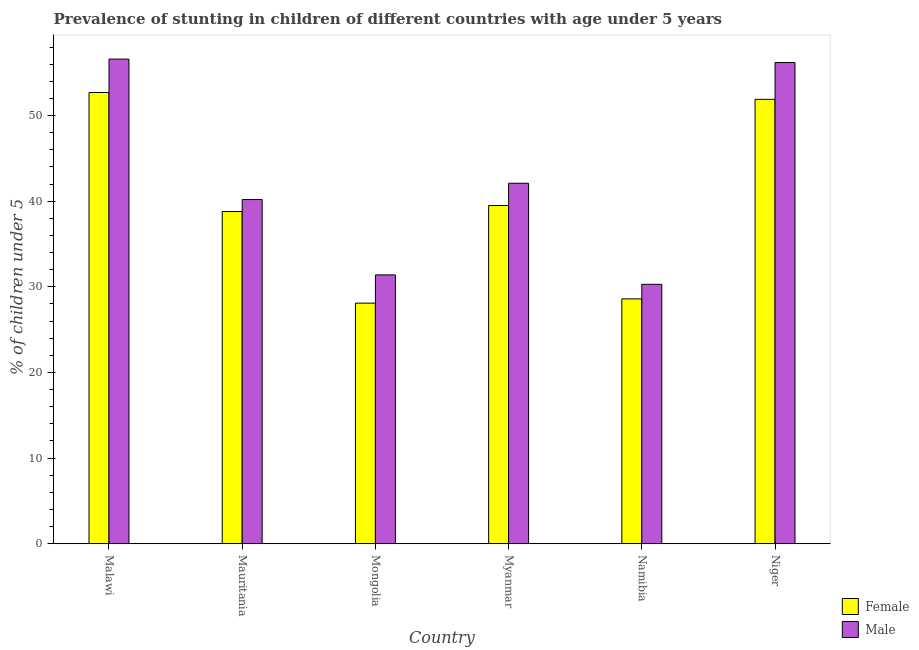How many different coloured bars are there?
Make the answer very short. 2. How many groups of bars are there?
Provide a short and direct response. 6. Are the number of bars per tick equal to the number of legend labels?
Your answer should be very brief. Yes. Are the number of bars on each tick of the X-axis equal?
Ensure brevity in your answer.  Yes. How many bars are there on the 2nd tick from the left?
Keep it short and to the point. 2. How many bars are there on the 5th tick from the right?
Make the answer very short. 2. What is the label of the 3rd group of bars from the left?
Offer a terse response. Mongolia. In how many cases, is the number of bars for a given country not equal to the number of legend labels?
Provide a succinct answer. 0. What is the percentage of stunted male children in Mauritania?
Provide a short and direct response. 40.2. Across all countries, what is the maximum percentage of stunted female children?
Your response must be concise. 52.7. Across all countries, what is the minimum percentage of stunted female children?
Provide a succinct answer. 28.1. In which country was the percentage of stunted male children maximum?
Provide a short and direct response. Malawi. In which country was the percentage of stunted female children minimum?
Your answer should be compact. Mongolia. What is the total percentage of stunted female children in the graph?
Offer a very short reply. 239.6. What is the difference between the percentage of stunted male children in Malawi and that in Namibia?
Make the answer very short. 26.3. What is the difference between the percentage of stunted female children in Niger and the percentage of stunted male children in Malawi?
Give a very brief answer. -4.7. What is the average percentage of stunted female children per country?
Give a very brief answer. 39.93. What is the difference between the percentage of stunted female children and percentage of stunted male children in Malawi?
Keep it short and to the point. -3.9. What is the ratio of the percentage of stunted female children in Mauritania to that in Niger?
Offer a very short reply. 0.75. Is the difference between the percentage of stunted male children in Mauritania and Namibia greater than the difference between the percentage of stunted female children in Mauritania and Namibia?
Your response must be concise. No. What is the difference between the highest and the second highest percentage of stunted male children?
Offer a very short reply. 0.4. What is the difference between the highest and the lowest percentage of stunted male children?
Your answer should be compact. 26.3. What does the 2nd bar from the left in Myanmar represents?
Offer a terse response. Male. What does the 2nd bar from the right in Myanmar represents?
Your answer should be compact. Female. Are all the bars in the graph horizontal?
Offer a very short reply. No. What is the difference between two consecutive major ticks on the Y-axis?
Offer a very short reply. 10. Does the graph contain grids?
Provide a short and direct response. No. Where does the legend appear in the graph?
Ensure brevity in your answer.  Bottom right. What is the title of the graph?
Give a very brief answer. Prevalence of stunting in children of different countries with age under 5 years. Does "Urban" appear as one of the legend labels in the graph?
Keep it short and to the point. No. What is the label or title of the X-axis?
Ensure brevity in your answer.  Country. What is the label or title of the Y-axis?
Provide a short and direct response.  % of children under 5. What is the  % of children under 5 in Female in Malawi?
Give a very brief answer. 52.7. What is the  % of children under 5 in Male in Malawi?
Keep it short and to the point. 56.6. What is the  % of children under 5 of Female in Mauritania?
Your response must be concise. 38.8. What is the  % of children under 5 in Male in Mauritania?
Your answer should be compact. 40.2. What is the  % of children under 5 in Female in Mongolia?
Your answer should be very brief. 28.1. What is the  % of children under 5 in Male in Mongolia?
Your response must be concise. 31.4. What is the  % of children under 5 of Female in Myanmar?
Keep it short and to the point. 39.5. What is the  % of children under 5 in Male in Myanmar?
Make the answer very short. 42.1. What is the  % of children under 5 of Female in Namibia?
Your answer should be compact. 28.6. What is the  % of children under 5 in Male in Namibia?
Ensure brevity in your answer.  30.3. What is the  % of children under 5 of Female in Niger?
Keep it short and to the point. 51.9. What is the  % of children under 5 of Male in Niger?
Your answer should be compact. 56.2. Across all countries, what is the maximum  % of children under 5 of Female?
Your answer should be compact. 52.7. Across all countries, what is the maximum  % of children under 5 of Male?
Provide a short and direct response. 56.6. Across all countries, what is the minimum  % of children under 5 in Female?
Offer a terse response. 28.1. Across all countries, what is the minimum  % of children under 5 in Male?
Your response must be concise. 30.3. What is the total  % of children under 5 in Female in the graph?
Give a very brief answer. 239.6. What is the total  % of children under 5 in Male in the graph?
Your answer should be compact. 256.8. What is the difference between the  % of children under 5 in Female in Malawi and that in Mauritania?
Provide a succinct answer. 13.9. What is the difference between the  % of children under 5 of Male in Malawi and that in Mauritania?
Keep it short and to the point. 16.4. What is the difference between the  % of children under 5 in Female in Malawi and that in Mongolia?
Offer a terse response. 24.6. What is the difference between the  % of children under 5 in Male in Malawi and that in Mongolia?
Provide a short and direct response. 25.2. What is the difference between the  % of children under 5 in Female in Malawi and that in Myanmar?
Make the answer very short. 13.2. What is the difference between the  % of children under 5 in Female in Malawi and that in Namibia?
Give a very brief answer. 24.1. What is the difference between the  % of children under 5 of Male in Malawi and that in Namibia?
Offer a very short reply. 26.3. What is the difference between the  % of children under 5 of Female in Mauritania and that in Mongolia?
Make the answer very short. 10.7. What is the difference between the  % of children under 5 in Female in Mauritania and that in Myanmar?
Provide a short and direct response. -0.7. What is the difference between the  % of children under 5 of Female in Mongolia and that in Myanmar?
Ensure brevity in your answer.  -11.4. What is the difference between the  % of children under 5 in Female in Mongolia and that in Namibia?
Ensure brevity in your answer.  -0.5. What is the difference between the  % of children under 5 in Male in Mongolia and that in Namibia?
Offer a very short reply. 1.1. What is the difference between the  % of children under 5 in Female in Mongolia and that in Niger?
Offer a very short reply. -23.8. What is the difference between the  % of children under 5 of Male in Mongolia and that in Niger?
Ensure brevity in your answer.  -24.8. What is the difference between the  % of children under 5 in Female in Myanmar and that in Namibia?
Give a very brief answer. 10.9. What is the difference between the  % of children under 5 in Male in Myanmar and that in Niger?
Provide a succinct answer. -14.1. What is the difference between the  % of children under 5 of Female in Namibia and that in Niger?
Your answer should be very brief. -23.3. What is the difference between the  % of children under 5 in Male in Namibia and that in Niger?
Your answer should be compact. -25.9. What is the difference between the  % of children under 5 in Female in Malawi and the  % of children under 5 in Male in Mongolia?
Provide a succinct answer. 21.3. What is the difference between the  % of children under 5 of Female in Malawi and the  % of children under 5 of Male in Namibia?
Make the answer very short. 22.4. What is the difference between the  % of children under 5 in Female in Malawi and the  % of children under 5 in Male in Niger?
Your response must be concise. -3.5. What is the difference between the  % of children under 5 of Female in Mauritania and the  % of children under 5 of Male in Mongolia?
Provide a succinct answer. 7.4. What is the difference between the  % of children under 5 in Female in Mauritania and the  % of children under 5 in Male in Namibia?
Your response must be concise. 8.5. What is the difference between the  % of children under 5 in Female in Mauritania and the  % of children under 5 in Male in Niger?
Provide a succinct answer. -17.4. What is the difference between the  % of children under 5 of Female in Mongolia and the  % of children under 5 of Male in Namibia?
Ensure brevity in your answer.  -2.2. What is the difference between the  % of children under 5 in Female in Mongolia and the  % of children under 5 in Male in Niger?
Offer a very short reply. -28.1. What is the difference between the  % of children under 5 in Female in Myanmar and the  % of children under 5 in Male in Namibia?
Your answer should be compact. 9.2. What is the difference between the  % of children under 5 in Female in Myanmar and the  % of children under 5 in Male in Niger?
Offer a terse response. -16.7. What is the difference between the  % of children under 5 in Female in Namibia and the  % of children under 5 in Male in Niger?
Keep it short and to the point. -27.6. What is the average  % of children under 5 of Female per country?
Make the answer very short. 39.93. What is the average  % of children under 5 of Male per country?
Your response must be concise. 42.8. What is the difference between the  % of children under 5 of Female and  % of children under 5 of Male in Malawi?
Your response must be concise. -3.9. What is the difference between the  % of children under 5 in Female and  % of children under 5 in Male in Namibia?
Offer a very short reply. -1.7. What is the difference between the  % of children under 5 of Female and  % of children under 5 of Male in Niger?
Provide a succinct answer. -4.3. What is the ratio of the  % of children under 5 in Female in Malawi to that in Mauritania?
Offer a very short reply. 1.36. What is the ratio of the  % of children under 5 of Male in Malawi to that in Mauritania?
Your answer should be compact. 1.41. What is the ratio of the  % of children under 5 in Female in Malawi to that in Mongolia?
Offer a terse response. 1.88. What is the ratio of the  % of children under 5 in Male in Malawi to that in Mongolia?
Provide a succinct answer. 1.8. What is the ratio of the  % of children under 5 of Female in Malawi to that in Myanmar?
Offer a terse response. 1.33. What is the ratio of the  % of children under 5 in Male in Malawi to that in Myanmar?
Offer a terse response. 1.34. What is the ratio of the  % of children under 5 of Female in Malawi to that in Namibia?
Your answer should be compact. 1.84. What is the ratio of the  % of children under 5 in Male in Malawi to that in Namibia?
Ensure brevity in your answer.  1.87. What is the ratio of the  % of children under 5 of Female in Malawi to that in Niger?
Make the answer very short. 1.02. What is the ratio of the  % of children under 5 in Male in Malawi to that in Niger?
Your answer should be compact. 1.01. What is the ratio of the  % of children under 5 in Female in Mauritania to that in Mongolia?
Keep it short and to the point. 1.38. What is the ratio of the  % of children under 5 in Male in Mauritania to that in Mongolia?
Provide a short and direct response. 1.28. What is the ratio of the  % of children under 5 of Female in Mauritania to that in Myanmar?
Make the answer very short. 0.98. What is the ratio of the  % of children under 5 in Male in Mauritania to that in Myanmar?
Ensure brevity in your answer.  0.95. What is the ratio of the  % of children under 5 of Female in Mauritania to that in Namibia?
Provide a short and direct response. 1.36. What is the ratio of the  % of children under 5 of Male in Mauritania to that in Namibia?
Offer a very short reply. 1.33. What is the ratio of the  % of children under 5 in Female in Mauritania to that in Niger?
Offer a very short reply. 0.75. What is the ratio of the  % of children under 5 in Male in Mauritania to that in Niger?
Your answer should be very brief. 0.72. What is the ratio of the  % of children under 5 in Female in Mongolia to that in Myanmar?
Your answer should be very brief. 0.71. What is the ratio of the  % of children under 5 of Male in Mongolia to that in Myanmar?
Keep it short and to the point. 0.75. What is the ratio of the  % of children under 5 of Female in Mongolia to that in Namibia?
Provide a short and direct response. 0.98. What is the ratio of the  % of children under 5 in Male in Mongolia to that in Namibia?
Make the answer very short. 1.04. What is the ratio of the  % of children under 5 of Female in Mongolia to that in Niger?
Give a very brief answer. 0.54. What is the ratio of the  % of children under 5 of Male in Mongolia to that in Niger?
Your answer should be compact. 0.56. What is the ratio of the  % of children under 5 of Female in Myanmar to that in Namibia?
Offer a terse response. 1.38. What is the ratio of the  % of children under 5 of Male in Myanmar to that in Namibia?
Your answer should be very brief. 1.39. What is the ratio of the  % of children under 5 of Female in Myanmar to that in Niger?
Offer a terse response. 0.76. What is the ratio of the  % of children under 5 of Male in Myanmar to that in Niger?
Your response must be concise. 0.75. What is the ratio of the  % of children under 5 in Female in Namibia to that in Niger?
Your answer should be compact. 0.55. What is the ratio of the  % of children under 5 of Male in Namibia to that in Niger?
Keep it short and to the point. 0.54. What is the difference between the highest and the second highest  % of children under 5 in Female?
Your answer should be compact. 0.8. What is the difference between the highest and the lowest  % of children under 5 of Female?
Your answer should be compact. 24.6. What is the difference between the highest and the lowest  % of children under 5 in Male?
Offer a very short reply. 26.3. 